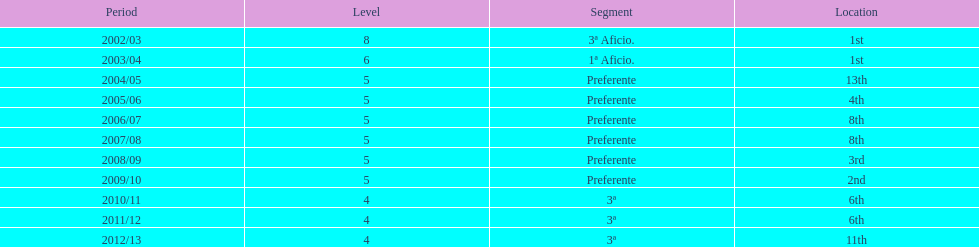How long has internacional de madrid cf been playing in the 3ª division? 3. 